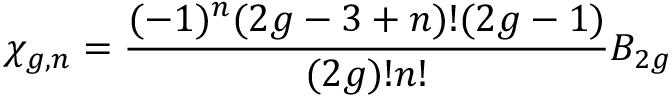<formula> <loc_0><loc_0><loc_500><loc_500>\chi _ { g , n } = { \frac { ( - 1 ) ^ { n } ( 2 g - 3 + n ) ! ( 2 g - 1 ) } { ( 2 g ) ! n ! } } B _ { 2 g }</formula> 